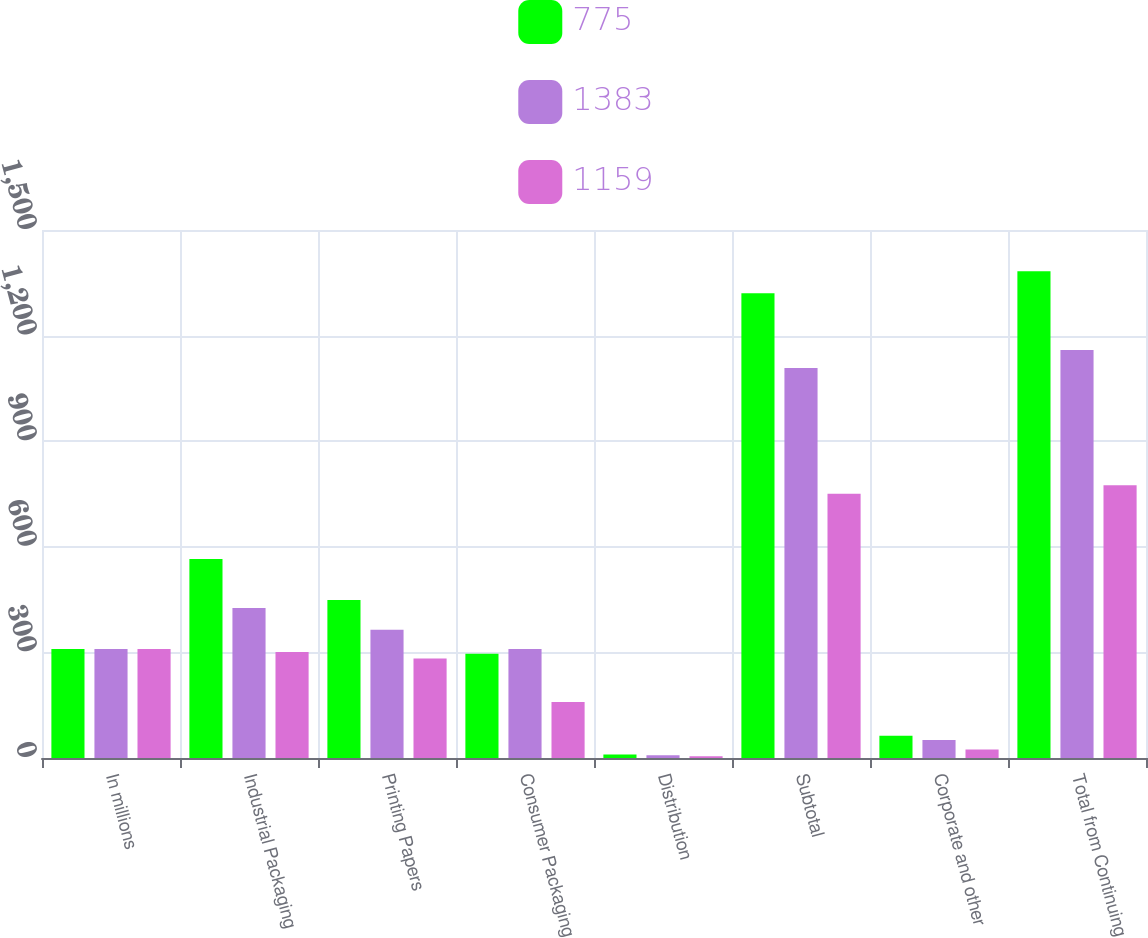Convert chart to OTSL. <chart><loc_0><loc_0><loc_500><loc_500><stacked_bar_chart><ecel><fcel>In millions<fcel>Industrial Packaging<fcel>Printing Papers<fcel>Consumer Packaging<fcel>Distribution<fcel>Subtotal<fcel>Corporate and other<fcel>Total from Continuing<nl><fcel>775<fcel>310<fcel>565<fcel>449<fcel>296<fcel>10<fcel>1320<fcel>63<fcel>1383<nl><fcel>1383<fcel>310<fcel>426<fcel>364<fcel>310<fcel>8<fcel>1108<fcel>51<fcel>1159<nl><fcel>1159<fcel>310<fcel>301<fcel>283<fcel>159<fcel>5<fcel>751<fcel>24<fcel>775<nl></chart> 